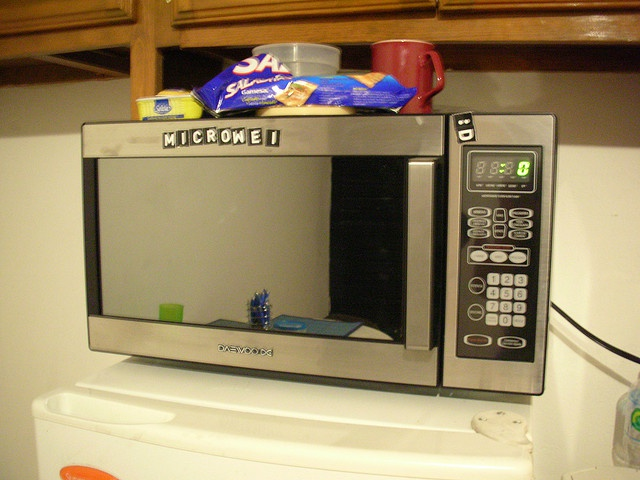Describe the objects in this image and their specific colors. I can see microwave in black, tan, and gray tones, cup in black, brown, and maroon tones, and bowl in black, tan, and gray tones in this image. 